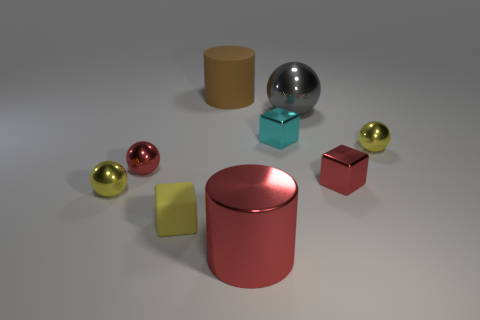Add 1 red balls. How many objects exist? 10 Subtract all tiny matte cubes. How many cubes are left? 2 Subtract all red cubes. How many cubes are left? 2 Subtract 2 cubes. How many cubes are left? 1 Add 2 cyan matte balls. How many cyan matte balls exist? 2 Subtract 0 purple balls. How many objects are left? 9 Subtract all cubes. How many objects are left? 6 Subtract all brown spheres. Subtract all blue cylinders. How many spheres are left? 4 Subtract all brown spheres. How many gray cylinders are left? 0 Subtract all large cyan metallic cylinders. Subtract all shiny cylinders. How many objects are left? 8 